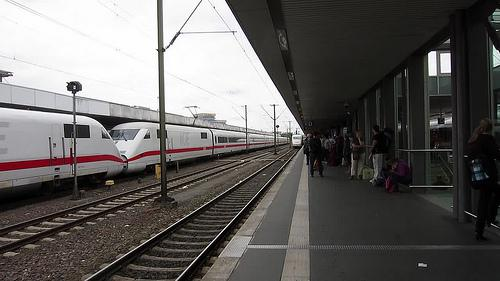Question: when was this photo taken?
Choices:
A. A few years ago.
B. Last night.
C. At sunrise.
D. During the day.
Answer with the letter. Answer: D Question: where was this photo taken?
Choices:
A. Outside at the train station.
B. In the kitchen.
C. At the river.
D. On the playground.
Answer with the letter. Answer: A Question: who are the people shown?
Choices:
A. Musicians.
B. Circus workers.
C. Travelers.
D. School children.
Answer with the letter. Answer: C Question: what is the train on?
Choices:
A. Shelf.
B. Museum display.
C. Sign.
D. The tracks.
Answer with the letter. Answer: D Question: why is the train not moving?
Choices:
A. It is broken.
B. It is parked.
C. People are boarding.
D. It is at a museum.
Answer with the letter. Answer: B Question: how many trains are there?
Choices:
A. 2.
B. 3.
C. 1.
D. 4.
Answer with the letter. Answer: A 